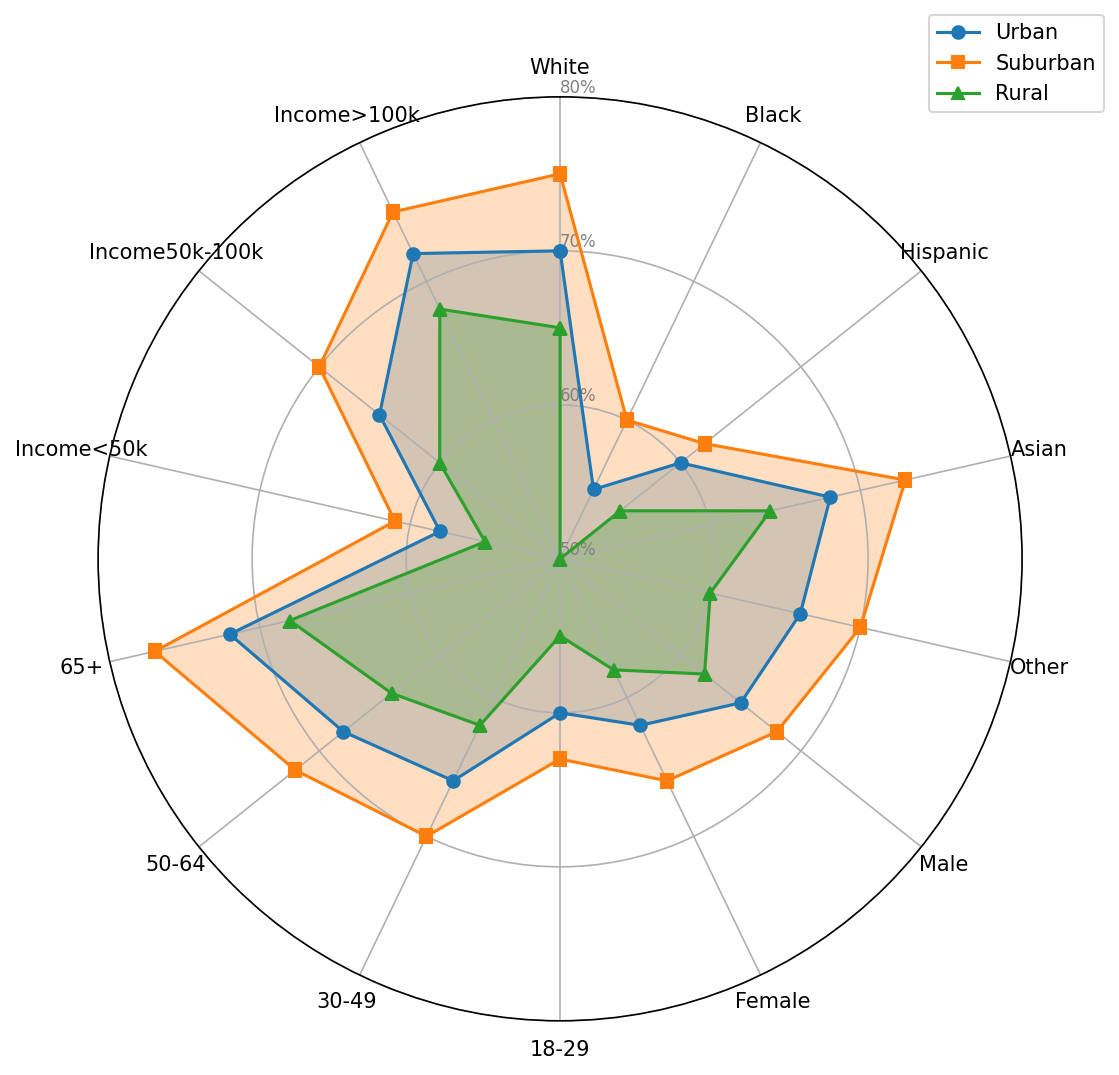Which community type has the highest confidence among White respondents? The line representing Suburban in the radar chart for the White category has the highest value.
Answer: Suburban What is the difference in confidence between Urban and Rural communities for Black respondents? The value for Black respondents in the Urban category is 55, and in the Rural category is 50. The difference can be calculated as 55 - 50 = 5.
Answer: 5 Which demographic shows the highest confidence in Suburban communities? By comparing the values for Suburban communities across all demographics, the "65+" category has the highest value at 77.
Answer: 65+ How does confidence in Urban communities compare between Male and Female respondents? The value for Male respondents in Urban communities is 65, and for Female respondents, it is 62. Males have higher confidence than Females in Urban communities.
Answer: Males have higher confidence What's the average confidence in Rural communities for Asian and Hispanic respondents? The value for Asian respondents is 64, and for Hispanic respondents, it is 55. The average can be calculated as (64 + 55) / 2 = 59.5.
Answer: 59.5 Which group shows the lowest confidence in Rural communities? By examining the radar chart, the Black respondents have the lowest confidence in Rural communities with a value of 50.
Answer: Black Do Male or Female respondents show higher confidence in Suburban communities? By comparing the values for Suburban communities, Male respondents have a confidence value of 68, while Female respondents have a value of 66. Males have higher confidence.
Answer: Males What is the sum of the confidence values for the "Other" demographic across all community types? The values for the "Other" demographic are 66 in Urban, 70 in Suburban, and 60 in Rural. The sum is 66 + 70 + 60 = 196.
Answer: 196 Which two demographic groups exhibit the same level of confidence in Suburban communities? The values for Suburban communities need to be compared across all demographic groups. "Income>100k" and "White" both show a confidence level of 75.
Answer: Income>100k and White 